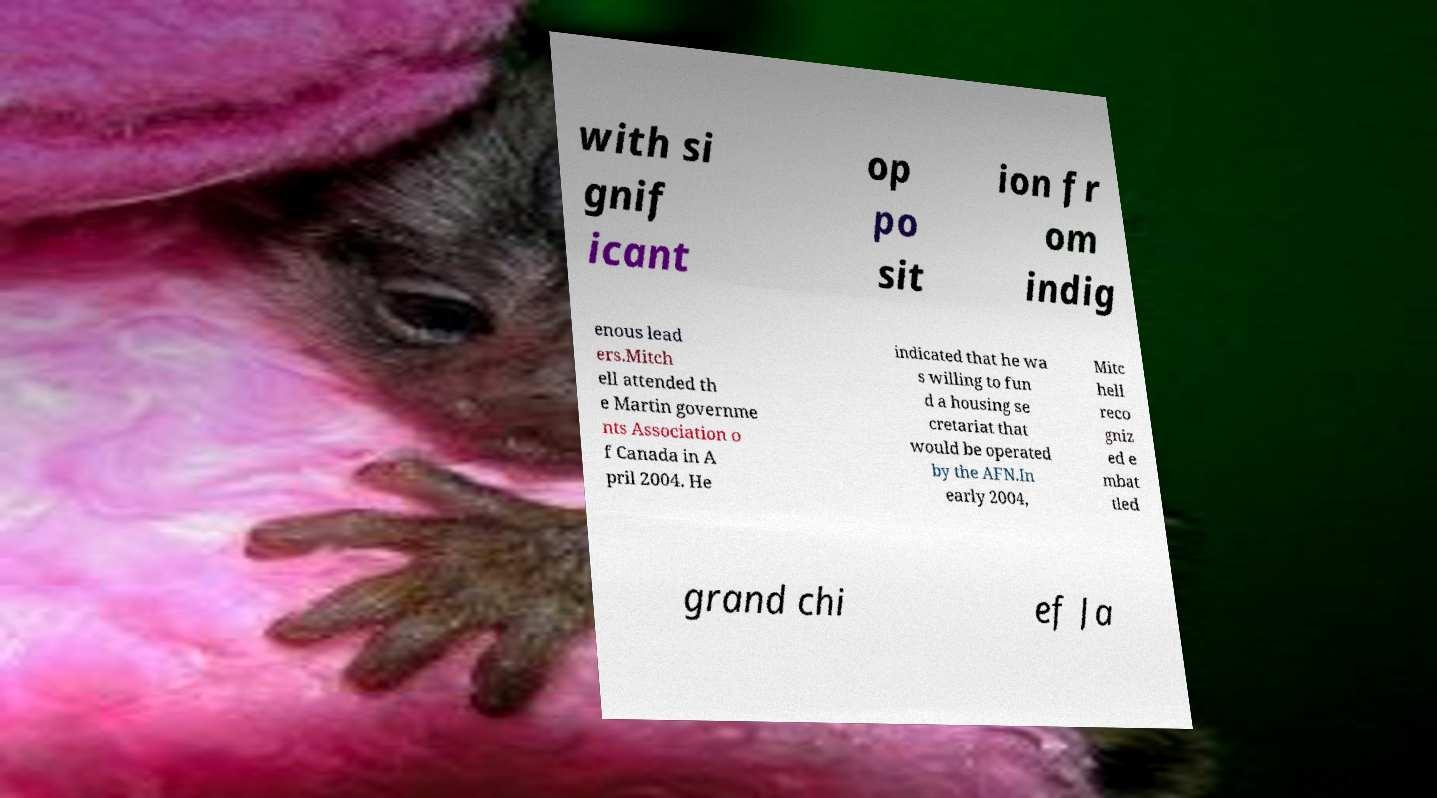Could you extract and type out the text from this image? with si gnif icant op po sit ion fr om indig enous lead ers.Mitch ell attended th e Martin governme nts Association o f Canada in A pril 2004. He indicated that he wa s willing to fun d a housing se cretariat that would be operated by the AFN.In early 2004, Mitc hell reco gniz ed e mbat tled grand chi ef Ja 